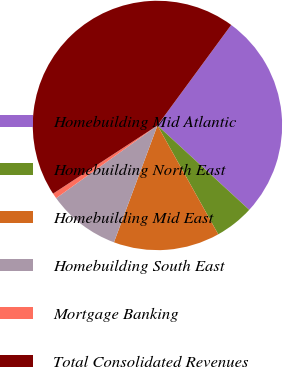Convert chart to OTSL. <chart><loc_0><loc_0><loc_500><loc_500><pie_chart><fcel>Homebuilding Mid Atlantic<fcel>Homebuilding North East<fcel>Homebuilding Mid East<fcel>Homebuilding South East<fcel>Mortgage Banking<fcel>Total Consolidated Revenues<nl><fcel>26.76%<fcel>5.06%<fcel>13.78%<fcel>9.42%<fcel>0.7%<fcel>44.29%<nl></chart> 